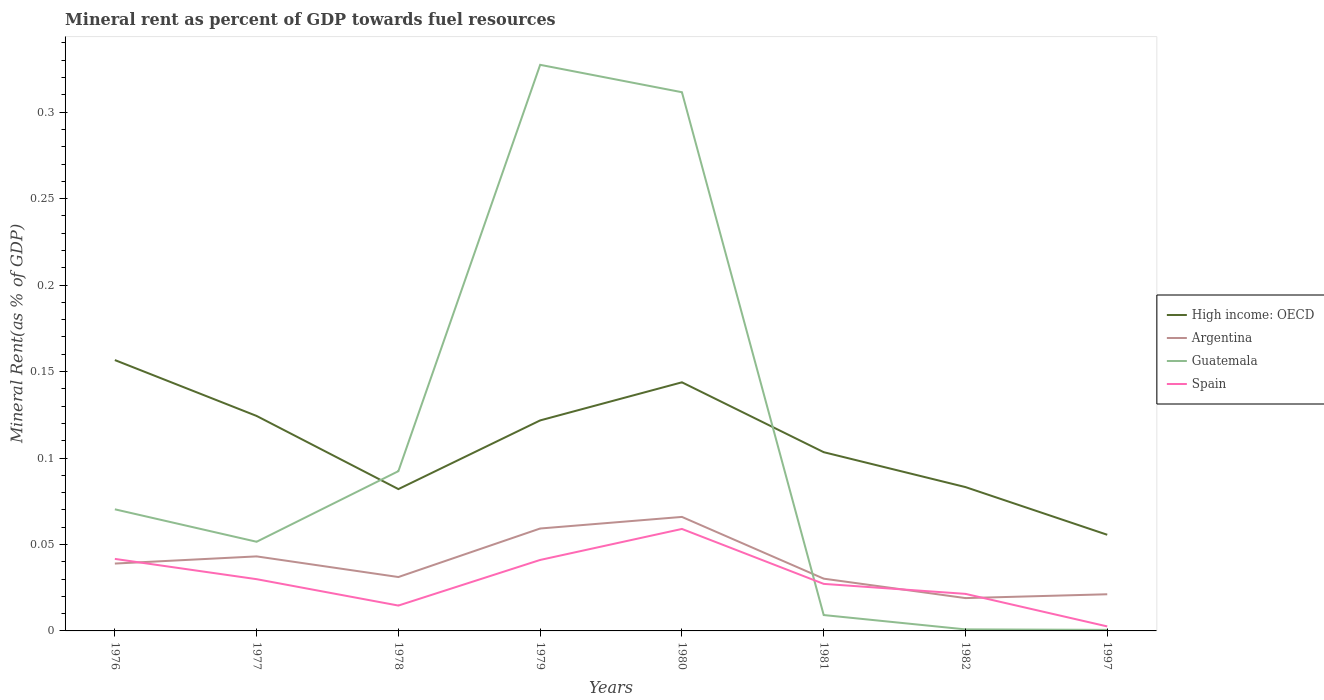How many different coloured lines are there?
Offer a terse response. 4. Does the line corresponding to High income: OECD intersect with the line corresponding to Guatemala?
Your response must be concise. Yes. Across all years, what is the maximum mineral rent in Spain?
Provide a succinct answer. 0. What is the total mineral rent in Guatemala in the graph?
Your answer should be very brief. 0.07. What is the difference between the highest and the second highest mineral rent in Spain?
Your answer should be very brief. 0.06. Is the mineral rent in Argentina strictly greater than the mineral rent in Guatemala over the years?
Ensure brevity in your answer.  No. How many lines are there?
Give a very brief answer. 4. How many years are there in the graph?
Ensure brevity in your answer.  8. Are the values on the major ticks of Y-axis written in scientific E-notation?
Offer a very short reply. No. Where does the legend appear in the graph?
Your answer should be very brief. Center right. How are the legend labels stacked?
Ensure brevity in your answer.  Vertical. What is the title of the graph?
Provide a succinct answer. Mineral rent as percent of GDP towards fuel resources. Does "Indonesia" appear as one of the legend labels in the graph?
Give a very brief answer. No. What is the label or title of the Y-axis?
Give a very brief answer. Mineral Rent(as % of GDP). What is the Mineral Rent(as % of GDP) in High income: OECD in 1976?
Offer a terse response. 0.16. What is the Mineral Rent(as % of GDP) in Argentina in 1976?
Provide a succinct answer. 0.04. What is the Mineral Rent(as % of GDP) of Guatemala in 1976?
Your response must be concise. 0.07. What is the Mineral Rent(as % of GDP) in Spain in 1976?
Your response must be concise. 0.04. What is the Mineral Rent(as % of GDP) of High income: OECD in 1977?
Provide a succinct answer. 0.12. What is the Mineral Rent(as % of GDP) of Argentina in 1977?
Ensure brevity in your answer.  0.04. What is the Mineral Rent(as % of GDP) of Guatemala in 1977?
Offer a very short reply. 0.05. What is the Mineral Rent(as % of GDP) in Spain in 1977?
Provide a short and direct response. 0.03. What is the Mineral Rent(as % of GDP) in High income: OECD in 1978?
Give a very brief answer. 0.08. What is the Mineral Rent(as % of GDP) of Argentina in 1978?
Provide a short and direct response. 0.03. What is the Mineral Rent(as % of GDP) of Guatemala in 1978?
Ensure brevity in your answer.  0.09. What is the Mineral Rent(as % of GDP) in Spain in 1978?
Make the answer very short. 0.01. What is the Mineral Rent(as % of GDP) of High income: OECD in 1979?
Make the answer very short. 0.12. What is the Mineral Rent(as % of GDP) in Argentina in 1979?
Ensure brevity in your answer.  0.06. What is the Mineral Rent(as % of GDP) of Guatemala in 1979?
Keep it short and to the point. 0.33. What is the Mineral Rent(as % of GDP) of Spain in 1979?
Offer a terse response. 0.04. What is the Mineral Rent(as % of GDP) of High income: OECD in 1980?
Offer a terse response. 0.14. What is the Mineral Rent(as % of GDP) in Argentina in 1980?
Keep it short and to the point. 0.07. What is the Mineral Rent(as % of GDP) of Guatemala in 1980?
Keep it short and to the point. 0.31. What is the Mineral Rent(as % of GDP) in Spain in 1980?
Keep it short and to the point. 0.06. What is the Mineral Rent(as % of GDP) in High income: OECD in 1981?
Your answer should be compact. 0.1. What is the Mineral Rent(as % of GDP) of Argentina in 1981?
Your response must be concise. 0.03. What is the Mineral Rent(as % of GDP) of Guatemala in 1981?
Your response must be concise. 0.01. What is the Mineral Rent(as % of GDP) of Spain in 1981?
Provide a short and direct response. 0.03. What is the Mineral Rent(as % of GDP) in High income: OECD in 1982?
Ensure brevity in your answer.  0.08. What is the Mineral Rent(as % of GDP) in Argentina in 1982?
Ensure brevity in your answer.  0.02. What is the Mineral Rent(as % of GDP) in Guatemala in 1982?
Offer a very short reply. 0. What is the Mineral Rent(as % of GDP) in Spain in 1982?
Make the answer very short. 0.02. What is the Mineral Rent(as % of GDP) in High income: OECD in 1997?
Give a very brief answer. 0.06. What is the Mineral Rent(as % of GDP) of Argentina in 1997?
Make the answer very short. 0.02. What is the Mineral Rent(as % of GDP) of Guatemala in 1997?
Your answer should be compact. 0. What is the Mineral Rent(as % of GDP) of Spain in 1997?
Provide a short and direct response. 0. Across all years, what is the maximum Mineral Rent(as % of GDP) of High income: OECD?
Your response must be concise. 0.16. Across all years, what is the maximum Mineral Rent(as % of GDP) of Argentina?
Keep it short and to the point. 0.07. Across all years, what is the maximum Mineral Rent(as % of GDP) in Guatemala?
Provide a succinct answer. 0.33. Across all years, what is the maximum Mineral Rent(as % of GDP) of Spain?
Provide a succinct answer. 0.06. Across all years, what is the minimum Mineral Rent(as % of GDP) in High income: OECD?
Your answer should be compact. 0.06. Across all years, what is the minimum Mineral Rent(as % of GDP) in Argentina?
Your response must be concise. 0.02. Across all years, what is the minimum Mineral Rent(as % of GDP) in Guatemala?
Give a very brief answer. 0. Across all years, what is the minimum Mineral Rent(as % of GDP) of Spain?
Your response must be concise. 0. What is the total Mineral Rent(as % of GDP) in High income: OECD in the graph?
Make the answer very short. 0.87. What is the total Mineral Rent(as % of GDP) in Argentina in the graph?
Provide a succinct answer. 0.31. What is the total Mineral Rent(as % of GDP) in Guatemala in the graph?
Offer a very short reply. 0.86. What is the total Mineral Rent(as % of GDP) of Spain in the graph?
Provide a succinct answer. 0.24. What is the difference between the Mineral Rent(as % of GDP) of High income: OECD in 1976 and that in 1977?
Your answer should be very brief. 0.03. What is the difference between the Mineral Rent(as % of GDP) of Argentina in 1976 and that in 1977?
Ensure brevity in your answer.  -0. What is the difference between the Mineral Rent(as % of GDP) in Guatemala in 1976 and that in 1977?
Provide a short and direct response. 0.02. What is the difference between the Mineral Rent(as % of GDP) of Spain in 1976 and that in 1977?
Your answer should be compact. 0.01. What is the difference between the Mineral Rent(as % of GDP) in High income: OECD in 1976 and that in 1978?
Keep it short and to the point. 0.07. What is the difference between the Mineral Rent(as % of GDP) of Argentina in 1976 and that in 1978?
Your response must be concise. 0.01. What is the difference between the Mineral Rent(as % of GDP) in Guatemala in 1976 and that in 1978?
Make the answer very short. -0.02. What is the difference between the Mineral Rent(as % of GDP) of Spain in 1976 and that in 1978?
Make the answer very short. 0.03. What is the difference between the Mineral Rent(as % of GDP) of High income: OECD in 1976 and that in 1979?
Keep it short and to the point. 0.03. What is the difference between the Mineral Rent(as % of GDP) in Argentina in 1976 and that in 1979?
Keep it short and to the point. -0.02. What is the difference between the Mineral Rent(as % of GDP) in Guatemala in 1976 and that in 1979?
Provide a succinct answer. -0.26. What is the difference between the Mineral Rent(as % of GDP) of Spain in 1976 and that in 1979?
Offer a very short reply. 0. What is the difference between the Mineral Rent(as % of GDP) of High income: OECD in 1976 and that in 1980?
Give a very brief answer. 0.01. What is the difference between the Mineral Rent(as % of GDP) of Argentina in 1976 and that in 1980?
Provide a short and direct response. -0.03. What is the difference between the Mineral Rent(as % of GDP) of Guatemala in 1976 and that in 1980?
Your response must be concise. -0.24. What is the difference between the Mineral Rent(as % of GDP) of Spain in 1976 and that in 1980?
Your answer should be very brief. -0.02. What is the difference between the Mineral Rent(as % of GDP) in High income: OECD in 1976 and that in 1981?
Provide a succinct answer. 0.05. What is the difference between the Mineral Rent(as % of GDP) of Argentina in 1976 and that in 1981?
Your answer should be very brief. 0.01. What is the difference between the Mineral Rent(as % of GDP) in Guatemala in 1976 and that in 1981?
Your answer should be very brief. 0.06. What is the difference between the Mineral Rent(as % of GDP) in Spain in 1976 and that in 1981?
Make the answer very short. 0.01. What is the difference between the Mineral Rent(as % of GDP) of High income: OECD in 1976 and that in 1982?
Offer a very short reply. 0.07. What is the difference between the Mineral Rent(as % of GDP) in Guatemala in 1976 and that in 1982?
Provide a succinct answer. 0.07. What is the difference between the Mineral Rent(as % of GDP) of Spain in 1976 and that in 1982?
Provide a succinct answer. 0.02. What is the difference between the Mineral Rent(as % of GDP) of High income: OECD in 1976 and that in 1997?
Give a very brief answer. 0.1. What is the difference between the Mineral Rent(as % of GDP) of Argentina in 1976 and that in 1997?
Offer a terse response. 0.02. What is the difference between the Mineral Rent(as % of GDP) of Guatemala in 1976 and that in 1997?
Give a very brief answer. 0.07. What is the difference between the Mineral Rent(as % of GDP) in Spain in 1976 and that in 1997?
Provide a succinct answer. 0.04. What is the difference between the Mineral Rent(as % of GDP) of High income: OECD in 1977 and that in 1978?
Your response must be concise. 0.04. What is the difference between the Mineral Rent(as % of GDP) in Argentina in 1977 and that in 1978?
Your answer should be very brief. 0.01. What is the difference between the Mineral Rent(as % of GDP) in Guatemala in 1977 and that in 1978?
Your response must be concise. -0.04. What is the difference between the Mineral Rent(as % of GDP) of Spain in 1977 and that in 1978?
Make the answer very short. 0.02. What is the difference between the Mineral Rent(as % of GDP) of High income: OECD in 1977 and that in 1979?
Offer a very short reply. 0. What is the difference between the Mineral Rent(as % of GDP) in Argentina in 1977 and that in 1979?
Keep it short and to the point. -0.02. What is the difference between the Mineral Rent(as % of GDP) of Guatemala in 1977 and that in 1979?
Make the answer very short. -0.28. What is the difference between the Mineral Rent(as % of GDP) of Spain in 1977 and that in 1979?
Your response must be concise. -0.01. What is the difference between the Mineral Rent(as % of GDP) of High income: OECD in 1977 and that in 1980?
Ensure brevity in your answer.  -0.02. What is the difference between the Mineral Rent(as % of GDP) of Argentina in 1977 and that in 1980?
Provide a short and direct response. -0.02. What is the difference between the Mineral Rent(as % of GDP) in Guatemala in 1977 and that in 1980?
Give a very brief answer. -0.26. What is the difference between the Mineral Rent(as % of GDP) in Spain in 1977 and that in 1980?
Offer a terse response. -0.03. What is the difference between the Mineral Rent(as % of GDP) in High income: OECD in 1977 and that in 1981?
Keep it short and to the point. 0.02. What is the difference between the Mineral Rent(as % of GDP) of Argentina in 1977 and that in 1981?
Ensure brevity in your answer.  0.01. What is the difference between the Mineral Rent(as % of GDP) in Guatemala in 1977 and that in 1981?
Make the answer very short. 0.04. What is the difference between the Mineral Rent(as % of GDP) in Spain in 1977 and that in 1981?
Provide a short and direct response. 0. What is the difference between the Mineral Rent(as % of GDP) in High income: OECD in 1977 and that in 1982?
Your answer should be compact. 0.04. What is the difference between the Mineral Rent(as % of GDP) of Argentina in 1977 and that in 1982?
Offer a very short reply. 0.02. What is the difference between the Mineral Rent(as % of GDP) of Guatemala in 1977 and that in 1982?
Make the answer very short. 0.05. What is the difference between the Mineral Rent(as % of GDP) in Spain in 1977 and that in 1982?
Your response must be concise. 0.01. What is the difference between the Mineral Rent(as % of GDP) in High income: OECD in 1977 and that in 1997?
Your answer should be compact. 0.07. What is the difference between the Mineral Rent(as % of GDP) of Argentina in 1977 and that in 1997?
Offer a very short reply. 0.02. What is the difference between the Mineral Rent(as % of GDP) of Guatemala in 1977 and that in 1997?
Your answer should be compact. 0.05. What is the difference between the Mineral Rent(as % of GDP) of Spain in 1977 and that in 1997?
Provide a succinct answer. 0.03. What is the difference between the Mineral Rent(as % of GDP) in High income: OECD in 1978 and that in 1979?
Your answer should be compact. -0.04. What is the difference between the Mineral Rent(as % of GDP) in Argentina in 1978 and that in 1979?
Offer a terse response. -0.03. What is the difference between the Mineral Rent(as % of GDP) of Guatemala in 1978 and that in 1979?
Give a very brief answer. -0.23. What is the difference between the Mineral Rent(as % of GDP) of Spain in 1978 and that in 1979?
Offer a very short reply. -0.03. What is the difference between the Mineral Rent(as % of GDP) of High income: OECD in 1978 and that in 1980?
Provide a succinct answer. -0.06. What is the difference between the Mineral Rent(as % of GDP) of Argentina in 1978 and that in 1980?
Keep it short and to the point. -0.03. What is the difference between the Mineral Rent(as % of GDP) of Guatemala in 1978 and that in 1980?
Ensure brevity in your answer.  -0.22. What is the difference between the Mineral Rent(as % of GDP) in Spain in 1978 and that in 1980?
Offer a very short reply. -0.04. What is the difference between the Mineral Rent(as % of GDP) in High income: OECD in 1978 and that in 1981?
Ensure brevity in your answer.  -0.02. What is the difference between the Mineral Rent(as % of GDP) in Argentina in 1978 and that in 1981?
Provide a short and direct response. 0. What is the difference between the Mineral Rent(as % of GDP) in Guatemala in 1978 and that in 1981?
Provide a short and direct response. 0.08. What is the difference between the Mineral Rent(as % of GDP) of Spain in 1978 and that in 1981?
Provide a short and direct response. -0.01. What is the difference between the Mineral Rent(as % of GDP) in High income: OECD in 1978 and that in 1982?
Offer a terse response. -0. What is the difference between the Mineral Rent(as % of GDP) in Argentina in 1978 and that in 1982?
Offer a terse response. 0.01. What is the difference between the Mineral Rent(as % of GDP) in Guatemala in 1978 and that in 1982?
Your answer should be compact. 0.09. What is the difference between the Mineral Rent(as % of GDP) in Spain in 1978 and that in 1982?
Your response must be concise. -0.01. What is the difference between the Mineral Rent(as % of GDP) in High income: OECD in 1978 and that in 1997?
Offer a very short reply. 0.03. What is the difference between the Mineral Rent(as % of GDP) of Argentina in 1978 and that in 1997?
Offer a very short reply. 0.01. What is the difference between the Mineral Rent(as % of GDP) in Guatemala in 1978 and that in 1997?
Offer a very short reply. 0.09. What is the difference between the Mineral Rent(as % of GDP) in Spain in 1978 and that in 1997?
Ensure brevity in your answer.  0.01. What is the difference between the Mineral Rent(as % of GDP) of High income: OECD in 1979 and that in 1980?
Provide a succinct answer. -0.02. What is the difference between the Mineral Rent(as % of GDP) of Argentina in 1979 and that in 1980?
Keep it short and to the point. -0.01. What is the difference between the Mineral Rent(as % of GDP) of Guatemala in 1979 and that in 1980?
Offer a very short reply. 0.02. What is the difference between the Mineral Rent(as % of GDP) in Spain in 1979 and that in 1980?
Make the answer very short. -0.02. What is the difference between the Mineral Rent(as % of GDP) in High income: OECD in 1979 and that in 1981?
Your answer should be very brief. 0.02. What is the difference between the Mineral Rent(as % of GDP) in Argentina in 1979 and that in 1981?
Give a very brief answer. 0.03. What is the difference between the Mineral Rent(as % of GDP) in Guatemala in 1979 and that in 1981?
Offer a terse response. 0.32. What is the difference between the Mineral Rent(as % of GDP) of Spain in 1979 and that in 1981?
Offer a terse response. 0.01. What is the difference between the Mineral Rent(as % of GDP) in High income: OECD in 1979 and that in 1982?
Make the answer very short. 0.04. What is the difference between the Mineral Rent(as % of GDP) in Argentina in 1979 and that in 1982?
Your response must be concise. 0.04. What is the difference between the Mineral Rent(as % of GDP) of Guatemala in 1979 and that in 1982?
Provide a short and direct response. 0.33. What is the difference between the Mineral Rent(as % of GDP) in Spain in 1979 and that in 1982?
Provide a short and direct response. 0.02. What is the difference between the Mineral Rent(as % of GDP) in High income: OECD in 1979 and that in 1997?
Make the answer very short. 0.07. What is the difference between the Mineral Rent(as % of GDP) of Argentina in 1979 and that in 1997?
Make the answer very short. 0.04. What is the difference between the Mineral Rent(as % of GDP) in Guatemala in 1979 and that in 1997?
Offer a terse response. 0.33. What is the difference between the Mineral Rent(as % of GDP) of Spain in 1979 and that in 1997?
Provide a succinct answer. 0.04. What is the difference between the Mineral Rent(as % of GDP) in High income: OECD in 1980 and that in 1981?
Your answer should be compact. 0.04. What is the difference between the Mineral Rent(as % of GDP) of Argentina in 1980 and that in 1981?
Provide a short and direct response. 0.04. What is the difference between the Mineral Rent(as % of GDP) in Guatemala in 1980 and that in 1981?
Offer a terse response. 0.3. What is the difference between the Mineral Rent(as % of GDP) in Spain in 1980 and that in 1981?
Make the answer very short. 0.03. What is the difference between the Mineral Rent(as % of GDP) of High income: OECD in 1980 and that in 1982?
Keep it short and to the point. 0.06. What is the difference between the Mineral Rent(as % of GDP) in Argentina in 1980 and that in 1982?
Provide a short and direct response. 0.05. What is the difference between the Mineral Rent(as % of GDP) in Guatemala in 1980 and that in 1982?
Provide a succinct answer. 0.31. What is the difference between the Mineral Rent(as % of GDP) of Spain in 1980 and that in 1982?
Your answer should be very brief. 0.04. What is the difference between the Mineral Rent(as % of GDP) of High income: OECD in 1980 and that in 1997?
Ensure brevity in your answer.  0.09. What is the difference between the Mineral Rent(as % of GDP) in Argentina in 1980 and that in 1997?
Your answer should be compact. 0.04. What is the difference between the Mineral Rent(as % of GDP) of Guatemala in 1980 and that in 1997?
Give a very brief answer. 0.31. What is the difference between the Mineral Rent(as % of GDP) of Spain in 1980 and that in 1997?
Ensure brevity in your answer.  0.06. What is the difference between the Mineral Rent(as % of GDP) of High income: OECD in 1981 and that in 1982?
Provide a succinct answer. 0.02. What is the difference between the Mineral Rent(as % of GDP) of Argentina in 1981 and that in 1982?
Provide a succinct answer. 0.01. What is the difference between the Mineral Rent(as % of GDP) of Guatemala in 1981 and that in 1982?
Your answer should be very brief. 0.01. What is the difference between the Mineral Rent(as % of GDP) in Spain in 1981 and that in 1982?
Offer a very short reply. 0.01. What is the difference between the Mineral Rent(as % of GDP) of High income: OECD in 1981 and that in 1997?
Your response must be concise. 0.05. What is the difference between the Mineral Rent(as % of GDP) of Argentina in 1981 and that in 1997?
Keep it short and to the point. 0.01. What is the difference between the Mineral Rent(as % of GDP) in Guatemala in 1981 and that in 1997?
Provide a short and direct response. 0.01. What is the difference between the Mineral Rent(as % of GDP) of Spain in 1981 and that in 1997?
Offer a terse response. 0.02. What is the difference between the Mineral Rent(as % of GDP) in High income: OECD in 1982 and that in 1997?
Offer a very short reply. 0.03. What is the difference between the Mineral Rent(as % of GDP) of Argentina in 1982 and that in 1997?
Your answer should be very brief. -0. What is the difference between the Mineral Rent(as % of GDP) in Spain in 1982 and that in 1997?
Provide a short and direct response. 0.02. What is the difference between the Mineral Rent(as % of GDP) in High income: OECD in 1976 and the Mineral Rent(as % of GDP) in Argentina in 1977?
Your response must be concise. 0.11. What is the difference between the Mineral Rent(as % of GDP) in High income: OECD in 1976 and the Mineral Rent(as % of GDP) in Guatemala in 1977?
Your response must be concise. 0.11. What is the difference between the Mineral Rent(as % of GDP) in High income: OECD in 1976 and the Mineral Rent(as % of GDP) in Spain in 1977?
Give a very brief answer. 0.13. What is the difference between the Mineral Rent(as % of GDP) of Argentina in 1976 and the Mineral Rent(as % of GDP) of Guatemala in 1977?
Provide a short and direct response. -0.01. What is the difference between the Mineral Rent(as % of GDP) in Argentina in 1976 and the Mineral Rent(as % of GDP) in Spain in 1977?
Offer a terse response. 0.01. What is the difference between the Mineral Rent(as % of GDP) in Guatemala in 1976 and the Mineral Rent(as % of GDP) in Spain in 1977?
Your response must be concise. 0.04. What is the difference between the Mineral Rent(as % of GDP) in High income: OECD in 1976 and the Mineral Rent(as % of GDP) in Argentina in 1978?
Keep it short and to the point. 0.13. What is the difference between the Mineral Rent(as % of GDP) in High income: OECD in 1976 and the Mineral Rent(as % of GDP) in Guatemala in 1978?
Make the answer very short. 0.06. What is the difference between the Mineral Rent(as % of GDP) in High income: OECD in 1976 and the Mineral Rent(as % of GDP) in Spain in 1978?
Your response must be concise. 0.14. What is the difference between the Mineral Rent(as % of GDP) of Argentina in 1976 and the Mineral Rent(as % of GDP) of Guatemala in 1978?
Your answer should be compact. -0.05. What is the difference between the Mineral Rent(as % of GDP) in Argentina in 1976 and the Mineral Rent(as % of GDP) in Spain in 1978?
Ensure brevity in your answer.  0.02. What is the difference between the Mineral Rent(as % of GDP) in Guatemala in 1976 and the Mineral Rent(as % of GDP) in Spain in 1978?
Your answer should be very brief. 0.06. What is the difference between the Mineral Rent(as % of GDP) of High income: OECD in 1976 and the Mineral Rent(as % of GDP) of Argentina in 1979?
Your answer should be compact. 0.1. What is the difference between the Mineral Rent(as % of GDP) in High income: OECD in 1976 and the Mineral Rent(as % of GDP) in Guatemala in 1979?
Offer a very short reply. -0.17. What is the difference between the Mineral Rent(as % of GDP) in High income: OECD in 1976 and the Mineral Rent(as % of GDP) in Spain in 1979?
Your response must be concise. 0.12. What is the difference between the Mineral Rent(as % of GDP) of Argentina in 1976 and the Mineral Rent(as % of GDP) of Guatemala in 1979?
Your answer should be compact. -0.29. What is the difference between the Mineral Rent(as % of GDP) of Argentina in 1976 and the Mineral Rent(as % of GDP) of Spain in 1979?
Your answer should be very brief. -0. What is the difference between the Mineral Rent(as % of GDP) of Guatemala in 1976 and the Mineral Rent(as % of GDP) of Spain in 1979?
Your answer should be compact. 0.03. What is the difference between the Mineral Rent(as % of GDP) in High income: OECD in 1976 and the Mineral Rent(as % of GDP) in Argentina in 1980?
Ensure brevity in your answer.  0.09. What is the difference between the Mineral Rent(as % of GDP) in High income: OECD in 1976 and the Mineral Rent(as % of GDP) in Guatemala in 1980?
Your answer should be very brief. -0.15. What is the difference between the Mineral Rent(as % of GDP) in High income: OECD in 1976 and the Mineral Rent(as % of GDP) in Spain in 1980?
Your answer should be very brief. 0.1. What is the difference between the Mineral Rent(as % of GDP) of Argentina in 1976 and the Mineral Rent(as % of GDP) of Guatemala in 1980?
Give a very brief answer. -0.27. What is the difference between the Mineral Rent(as % of GDP) in Argentina in 1976 and the Mineral Rent(as % of GDP) in Spain in 1980?
Make the answer very short. -0.02. What is the difference between the Mineral Rent(as % of GDP) of Guatemala in 1976 and the Mineral Rent(as % of GDP) of Spain in 1980?
Provide a short and direct response. 0.01. What is the difference between the Mineral Rent(as % of GDP) in High income: OECD in 1976 and the Mineral Rent(as % of GDP) in Argentina in 1981?
Keep it short and to the point. 0.13. What is the difference between the Mineral Rent(as % of GDP) in High income: OECD in 1976 and the Mineral Rent(as % of GDP) in Guatemala in 1981?
Keep it short and to the point. 0.15. What is the difference between the Mineral Rent(as % of GDP) of High income: OECD in 1976 and the Mineral Rent(as % of GDP) of Spain in 1981?
Give a very brief answer. 0.13. What is the difference between the Mineral Rent(as % of GDP) of Argentina in 1976 and the Mineral Rent(as % of GDP) of Guatemala in 1981?
Offer a terse response. 0.03. What is the difference between the Mineral Rent(as % of GDP) in Argentina in 1976 and the Mineral Rent(as % of GDP) in Spain in 1981?
Offer a very short reply. 0.01. What is the difference between the Mineral Rent(as % of GDP) of Guatemala in 1976 and the Mineral Rent(as % of GDP) of Spain in 1981?
Make the answer very short. 0.04. What is the difference between the Mineral Rent(as % of GDP) in High income: OECD in 1976 and the Mineral Rent(as % of GDP) in Argentina in 1982?
Ensure brevity in your answer.  0.14. What is the difference between the Mineral Rent(as % of GDP) of High income: OECD in 1976 and the Mineral Rent(as % of GDP) of Guatemala in 1982?
Make the answer very short. 0.16. What is the difference between the Mineral Rent(as % of GDP) in High income: OECD in 1976 and the Mineral Rent(as % of GDP) in Spain in 1982?
Your answer should be very brief. 0.14. What is the difference between the Mineral Rent(as % of GDP) in Argentina in 1976 and the Mineral Rent(as % of GDP) in Guatemala in 1982?
Give a very brief answer. 0.04. What is the difference between the Mineral Rent(as % of GDP) in Argentina in 1976 and the Mineral Rent(as % of GDP) in Spain in 1982?
Offer a terse response. 0.02. What is the difference between the Mineral Rent(as % of GDP) of Guatemala in 1976 and the Mineral Rent(as % of GDP) of Spain in 1982?
Your answer should be very brief. 0.05. What is the difference between the Mineral Rent(as % of GDP) in High income: OECD in 1976 and the Mineral Rent(as % of GDP) in Argentina in 1997?
Ensure brevity in your answer.  0.14. What is the difference between the Mineral Rent(as % of GDP) in High income: OECD in 1976 and the Mineral Rent(as % of GDP) in Guatemala in 1997?
Provide a succinct answer. 0.16. What is the difference between the Mineral Rent(as % of GDP) in High income: OECD in 1976 and the Mineral Rent(as % of GDP) in Spain in 1997?
Your answer should be compact. 0.15. What is the difference between the Mineral Rent(as % of GDP) of Argentina in 1976 and the Mineral Rent(as % of GDP) of Guatemala in 1997?
Your answer should be very brief. 0.04. What is the difference between the Mineral Rent(as % of GDP) of Argentina in 1976 and the Mineral Rent(as % of GDP) of Spain in 1997?
Your response must be concise. 0.04. What is the difference between the Mineral Rent(as % of GDP) in Guatemala in 1976 and the Mineral Rent(as % of GDP) in Spain in 1997?
Ensure brevity in your answer.  0.07. What is the difference between the Mineral Rent(as % of GDP) of High income: OECD in 1977 and the Mineral Rent(as % of GDP) of Argentina in 1978?
Your answer should be compact. 0.09. What is the difference between the Mineral Rent(as % of GDP) of High income: OECD in 1977 and the Mineral Rent(as % of GDP) of Guatemala in 1978?
Make the answer very short. 0.03. What is the difference between the Mineral Rent(as % of GDP) of High income: OECD in 1977 and the Mineral Rent(as % of GDP) of Spain in 1978?
Offer a terse response. 0.11. What is the difference between the Mineral Rent(as % of GDP) of Argentina in 1977 and the Mineral Rent(as % of GDP) of Guatemala in 1978?
Make the answer very short. -0.05. What is the difference between the Mineral Rent(as % of GDP) in Argentina in 1977 and the Mineral Rent(as % of GDP) in Spain in 1978?
Keep it short and to the point. 0.03. What is the difference between the Mineral Rent(as % of GDP) in Guatemala in 1977 and the Mineral Rent(as % of GDP) in Spain in 1978?
Make the answer very short. 0.04. What is the difference between the Mineral Rent(as % of GDP) of High income: OECD in 1977 and the Mineral Rent(as % of GDP) of Argentina in 1979?
Offer a terse response. 0.07. What is the difference between the Mineral Rent(as % of GDP) of High income: OECD in 1977 and the Mineral Rent(as % of GDP) of Guatemala in 1979?
Give a very brief answer. -0.2. What is the difference between the Mineral Rent(as % of GDP) in High income: OECD in 1977 and the Mineral Rent(as % of GDP) in Spain in 1979?
Provide a succinct answer. 0.08. What is the difference between the Mineral Rent(as % of GDP) in Argentina in 1977 and the Mineral Rent(as % of GDP) in Guatemala in 1979?
Make the answer very short. -0.28. What is the difference between the Mineral Rent(as % of GDP) of Argentina in 1977 and the Mineral Rent(as % of GDP) of Spain in 1979?
Provide a succinct answer. 0. What is the difference between the Mineral Rent(as % of GDP) of Guatemala in 1977 and the Mineral Rent(as % of GDP) of Spain in 1979?
Your response must be concise. 0.01. What is the difference between the Mineral Rent(as % of GDP) in High income: OECD in 1977 and the Mineral Rent(as % of GDP) in Argentina in 1980?
Your answer should be very brief. 0.06. What is the difference between the Mineral Rent(as % of GDP) of High income: OECD in 1977 and the Mineral Rent(as % of GDP) of Guatemala in 1980?
Offer a very short reply. -0.19. What is the difference between the Mineral Rent(as % of GDP) of High income: OECD in 1977 and the Mineral Rent(as % of GDP) of Spain in 1980?
Keep it short and to the point. 0.07. What is the difference between the Mineral Rent(as % of GDP) of Argentina in 1977 and the Mineral Rent(as % of GDP) of Guatemala in 1980?
Provide a succinct answer. -0.27. What is the difference between the Mineral Rent(as % of GDP) in Argentina in 1977 and the Mineral Rent(as % of GDP) in Spain in 1980?
Ensure brevity in your answer.  -0.02. What is the difference between the Mineral Rent(as % of GDP) in Guatemala in 1977 and the Mineral Rent(as % of GDP) in Spain in 1980?
Your answer should be very brief. -0.01. What is the difference between the Mineral Rent(as % of GDP) in High income: OECD in 1977 and the Mineral Rent(as % of GDP) in Argentina in 1981?
Offer a very short reply. 0.09. What is the difference between the Mineral Rent(as % of GDP) in High income: OECD in 1977 and the Mineral Rent(as % of GDP) in Guatemala in 1981?
Keep it short and to the point. 0.12. What is the difference between the Mineral Rent(as % of GDP) in High income: OECD in 1977 and the Mineral Rent(as % of GDP) in Spain in 1981?
Keep it short and to the point. 0.1. What is the difference between the Mineral Rent(as % of GDP) of Argentina in 1977 and the Mineral Rent(as % of GDP) of Guatemala in 1981?
Provide a short and direct response. 0.03. What is the difference between the Mineral Rent(as % of GDP) in Argentina in 1977 and the Mineral Rent(as % of GDP) in Spain in 1981?
Provide a succinct answer. 0.02. What is the difference between the Mineral Rent(as % of GDP) in Guatemala in 1977 and the Mineral Rent(as % of GDP) in Spain in 1981?
Offer a terse response. 0.02. What is the difference between the Mineral Rent(as % of GDP) in High income: OECD in 1977 and the Mineral Rent(as % of GDP) in Argentina in 1982?
Offer a very short reply. 0.11. What is the difference between the Mineral Rent(as % of GDP) in High income: OECD in 1977 and the Mineral Rent(as % of GDP) in Guatemala in 1982?
Give a very brief answer. 0.12. What is the difference between the Mineral Rent(as % of GDP) of High income: OECD in 1977 and the Mineral Rent(as % of GDP) of Spain in 1982?
Keep it short and to the point. 0.1. What is the difference between the Mineral Rent(as % of GDP) in Argentina in 1977 and the Mineral Rent(as % of GDP) in Guatemala in 1982?
Keep it short and to the point. 0.04. What is the difference between the Mineral Rent(as % of GDP) of Argentina in 1977 and the Mineral Rent(as % of GDP) of Spain in 1982?
Make the answer very short. 0.02. What is the difference between the Mineral Rent(as % of GDP) in Guatemala in 1977 and the Mineral Rent(as % of GDP) in Spain in 1982?
Make the answer very short. 0.03. What is the difference between the Mineral Rent(as % of GDP) of High income: OECD in 1977 and the Mineral Rent(as % of GDP) of Argentina in 1997?
Provide a short and direct response. 0.1. What is the difference between the Mineral Rent(as % of GDP) of High income: OECD in 1977 and the Mineral Rent(as % of GDP) of Guatemala in 1997?
Your answer should be very brief. 0.12. What is the difference between the Mineral Rent(as % of GDP) of High income: OECD in 1977 and the Mineral Rent(as % of GDP) of Spain in 1997?
Your response must be concise. 0.12. What is the difference between the Mineral Rent(as % of GDP) of Argentina in 1977 and the Mineral Rent(as % of GDP) of Guatemala in 1997?
Ensure brevity in your answer.  0.04. What is the difference between the Mineral Rent(as % of GDP) of Argentina in 1977 and the Mineral Rent(as % of GDP) of Spain in 1997?
Keep it short and to the point. 0.04. What is the difference between the Mineral Rent(as % of GDP) of Guatemala in 1977 and the Mineral Rent(as % of GDP) of Spain in 1997?
Provide a succinct answer. 0.05. What is the difference between the Mineral Rent(as % of GDP) of High income: OECD in 1978 and the Mineral Rent(as % of GDP) of Argentina in 1979?
Ensure brevity in your answer.  0.02. What is the difference between the Mineral Rent(as % of GDP) of High income: OECD in 1978 and the Mineral Rent(as % of GDP) of Guatemala in 1979?
Your response must be concise. -0.25. What is the difference between the Mineral Rent(as % of GDP) of High income: OECD in 1978 and the Mineral Rent(as % of GDP) of Spain in 1979?
Provide a short and direct response. 0.04. What is the difference between the Mineral Rent(as % of GDP) of Argentina in 1978 and the Mineral Rent(as % of GDP) of Guatemala in 1979?
Your response must be concise. -0.3. What is the difference between the Mineral Rent(as % of GDP) of Argentina in 1978 and the Mineral Rent(as % of GDP) of Spain in 1979?
Your answer should be very brief. -0.01. What is the difference between the Mineral Rent(as % of GDP) of Guatemala in 1978 and the Mineral Rent(as % of GDP) of Spain in 1979?
Give a very brief answer. 0.05. What is the difference between the Mineral Rent(as % of GDP) in High income: OECD in 1978 and the Mineral Rent(as % of GDP) in Argentina in 1980?
Ensure brevity in your answer.  0.02. What is the difference between the Mineral Rent(as % of GDP) in High income: OECD in 1978 and the Mineral Rent(as % of GDP) in Guatemala in 1980?
Make the answer very short. -0.23. What is the difference between the Mineral Rent(as % of GDP) in High income: OECD in 1978 and the Mineral Rent(as % of GDP) in Spain in 1980?
Your response must be concise. 0.02. What is the difference between the Mineral Rent(as % of GDP) in Argentina in 1978 and the Mineral Rent(as % of GDP) in Guatemala in 1980?
Keep it short and to the point. -0.28. What is the difference between the Mineral Rent(as % of GDP) in Argentina in 1978 and the Mineral Rent(as % of GDP) in Spain in 1980?
Offer a very short reply. -0.03. What is the difference between the Mineral Rent(as % of GDP) of Guatemala in 1978 and the Mineral Rent(as % of GDP) of Spain in 1980?
Offer a terse response. 0.03. What is the difference between the Mineral Rent(as % of GDP) in High income: OECD in 1978 and the Mineral Rent(as % of GDP) in Argentina in 1981?
Your response must be concise. 0.05. What is the difference between the Mineral Rent(as % of GDP) of High income: OECD in 1978 and the Mineral Rent(as % of GDP) of Guatemala in 1981?
Your response must be concise. 0.07. What is the difference between the Mineral Rent(as % of GDP) of High income: OECD in 1978 and the Mineral Rent(as % of GDP) of Spain in 1981?
Give a very brief answer. 0.05. What is the difference between the Mineral Rent(as % of GDP) of Argentina in 1978 and the Mineral Rent(as % of GDP) of Guatemala in 1981?
Ensure brevity in your answer.  0.02. What is the difference between the Mineral Rent(as % of GDP) in Argentina in 1978 and the Mineral Rent(as % of GDP) in Spain in 1981?
Provide a short and direct response. 0. What is the difference between the Mineral Rent(as % of GDP) in Guatemala in 1978 and the Mineral Rent(as % of GDP) in Spain in 1981?
Your answer should be compact. 0.07. What is the difference between the Mineral Rent(as % of GDP) of High income: OECD in 1978 and the Mineral Rent(as % of GDP) of Argentina in 1982?
Offer a terse response. 0.06. What is the difference between the Mineral Rent(as % of GDP) in High income: OECD in 1978 and the Mineral Rent(as % of GDP) in Guatemala in 1982?
Offer a terse response. 0.08. What is the difference between the Mineral Rent(as % of GDP) of High income: OECD in 1978 and the Mineral Rent(as % of GDP) of Spain in 1982?
Your answer should be compact. 0.06. What is the difference between the Mineral Rent(as % of GDP) of Argentina in 1978 and the Mineral Rent(as % of GDP) of Guatemala in 1982?
Your answer should be compact. 0.03. What is the difference between the Mineral Rent(as % of GDP) in Argentina in 1978 and the Mineral Rent(as % of GDP) in Spain in 1982?
Ensure brevity in your answer.  0.01. What is the difference between the Mineral Rent(as % of GDP) in Guatemala in 1978 and the Mineral Rent(as % of GDP) in Spain in 1982?
Keep it short and to the point. 0.07. What is the difference between the Mineral Rent(as % of GDP) in High income: OECD in 1978 and the Mineral Rent(as % of GDP) in Argentina in 1997?
Provide a short and direct response. 0.06. What is the difference between the Mineral Rent(as % of GDP) of High income: OECD in 1978 and the Mineral Rent(as % of GDP) of Guatemala in 1997?
Ensure brevity in your answer.  0.08. What is the difference between the Mineral Rent(as % of GDP) in High income: OECD in 1978 and the Mineral Rent(as % of GDP) in Spain in 1997?
Make the answer very short. 0.08. What is the difference between the Mineral Rent(as % of GDP) of Argentina in 1978 and the Mineral Rent(as % of GDP) of Guatemala in 1997?
Your response must be concise. 0.03. What is the difference between the Mineral Rent(as % of GDP) of Argentina in 1978 and the Mineral Rent(as % of GDP) of Spain in 1997?
Your response must be concise. 0.03. What is the difference between the Mineral Rent(as % of GDP) of Guatemala in 1978 and the Mineral Rent(as % of GDP) of Spain in 1997?
Provide a succinct answer. 0.09. What is the difference between the Mineral Rent(as % of GDP) in High income: OECD in 1979 and the Mineral Rent(as % of GDP) in Argentina in 1980?
Your response must be concise. 0.06. What is the difference between the Mineral Rent(as % of GDP) of High income: OECD in 1979 and the Mineral Rent(as % of GDP) of Guatemala in 1980?
Offer a very short reply. -0.19. What is the difference between the Mineral Rent(as % of GDP) in High income: OECD in 1979 and the Mineral Rent(as % of GDP) in Spain in 1980?
Provide a succinct answer. 0.06. What is the difference between the Mineral Rent(as % of GDP) of Argentina in 1979 and the Mineral Rent(as % of GDP) of Guatemala in 1980?
Your response must be concise. -0.25. What is the difference between the Mineral Rent(as % of GDP) in Guatemala in 1979 and the Mineral Rent(as % of GDP) in Spain in 1980?
Offer a terse response. 0.27. What is the difference between the Mineral Rent(as % of GDP) of High income: OECD in 1979 and the Mineral Rent(as % of GDP) of Argentina in 1981?
Give a very brief answer. 0.09. What is the difference between the Mineral Rent(as % of GDP) of High income: OECD in 1979 and the Mineral Rent(as % of GDP) of Guatemala in 1981?
Give a very brief answer. 0.11. What is the difference between the Mineral Rent(as % of GDP) of High income: OECD in 1979 and the Mineral Rent(as % of GDP) of Spain in 1981?
Keep it short and to the point. 0.09. What is the difference between the Mineral Rent(as % of GDP) of Argentina in 1979 and the Mineral Rent(as % of GDP) of Spain in 1981?
Your answer should be very brief. 0.03. What is the difference between the Mineral Rent(as % of GDP) in Guatemala in 1979 and the Mineral Rent(as % of GDP) in Spain in 1981?
Your response must be concise. 0.3. What is the difference between the Mineral Rent(as % of GDP) of High income: OECD in 1979 and the Mineral Rent(as % of GDP) of Argentina in 1982?
Offer a very short reply. 0.1. What is the difference between the Mineral Rent(as % of GDP) of High income: OECD in 1979 and the Mineral Rent(as % of GDP) of Guatemala in 1982?
Provide a short and direct response. 0.12. What is the difference between the Mineral Rent(as % of GDP) in High income: OECD in 1979 and the Mineral Rent(as % of GDP) in Spain in 1982?
Provide a succinct answer. 0.1. What is the difference between the Mineral Rent(as % of GDP) in Argentina in 1979 and the Mineral Rent(as % of GDP) in Guatemala in 1982?
Provide a succinct answer. 0.06. What is the difference between the Mineral Rent(as % of GDP) in Argentina in 1979 and the Mineral Rent(as % of GDP) in Spain in 1982?
Ensure brevity in your answer.  0.04. What is the difference between the Mineral Rent(as % of GDP) of Guatemala in 1979 and the Mineral Rent(as % of GDP) of Spain in 1982?
Your answer should be very brief. 0.31. What is the difference between the Mineral Rent(as % of GDP) in High income: OECD in 1979 and the Mineral Rent(as % of GDP) in Argentina in 1997?
Give a very brief answer. 0.1. What is the difference between the Mineral Rent(as % of GDP) in High income: OECD in 1979 and the Mineral Rent(as % of GDP) in Guatemala in 1997?
Ensure brevity in your answer.  0.12. What is the difference between the Mineral Rent(as % of GDP) of High income: OECD in 1979 and the Mineral Rent(as % of GDP) of Spain in 1997?
Keep it short and to the point. 0.12. What is the difference between the Mineral Rent(as % of GDP) of Argentina in 1979 and the Mineral Rent(as % of GDP) of Guatemala in 1997?
Offer a terse response. 0.06. What is the difference between the Mineral Rent(as % of GDP) of Argentina in 1979 and the Mineral Rent(as % of GDP) of Spain in 1997?
Ensure brevity in your answer.  0.06. What is the difference between the Mineral Rent(as % of GDP) in Guatemala in 1979 and the Mineral Rent(as % of GDP) in Spain in 1997?
Provide a succinct answer. 0.32. What is the difference between the Mineral Rent(as % of GDP) in High income: OECD in 1980 and the Mineral Rent(as % of GDP) in Argentina in 1981?
Provide a succinct answer. 0.11. What is the difference between the Mineral Rent(as % of GDP) of High income: OECD in 1980 and the Mineral Rent(as % of GDP) of Guatemala in 1981?
Make the answer very short. 0.13. What is the difference between the Mineral Rent(as % of GDP) in High income: OECD in 1980 and the Mineral Rent(as % of GDP) in Spain in 1981?
Your response must be concise. 0.12. What is the difference between the Mineral Rent(as % of GDP) in Argentina in 1980 and the Mineral Rent(as % of GDP) in Guatemala in 1981?
Provide a short and direct response. 0.06. What is the difference between the Mineral Rent(as % of GDP) of Argentina in 1980 and the Mineral Rent(as % of GDP) of Spain in 1981?
Ensure brevity in your answer.  0.04. What is the difference between the Mineral Rent(as % of GDP) of Guatemala in 1980 and the Mineral Rent(as % of GDP) of Spain in 1981?
Offer a terse response. 0.28. What is the difference between the Mineral Rent(as % of GDP) of High income: OECD in 1980 and the Mineral Rent(as % of GDP) of Argentina in 1982?
Keep it short and to the point. 0.12. What is the difference between the Mineral Rent(as % of GDP) of High income: OECD in 1980 and the Mineral Rent(as % of GDP) of Guatemala in 1982?
Ensure brevity in your answer.  0.14. What is the difference between the Mineral Rent(as % of GDP) in High income: OECD in 1980 and the Mineral Rent(as % of GDP) in Spain in 1982?
Offer a very short reply. 0.12. What is the difference between the Mineral Rent(as % of GDP) in Argentina in 1980 and the Mineral Rent(as % of GDP) in Guatemala in 1982?
Keep it short and to the point. 0.07. What is the difference between the Mineral Rent(as % of GDP) in Argentina in 1980 and the Mineral Rent(as % of GDP) in Spain in 1982?
Give a very brief answer. 0.04. What is the difference between the Mineral Rent(as % of GDP) in Guatemala in 1980 and the Mineral Rent(as % of GDP) in Spain in 1982?
Your answer should be very brief. 0.29. What is the difference between the Mineral Rent(as % of GDP) of High income: OECD in 1980 and the Mineral Rent(as % of GDP) of Argentina in 1997?
Offer a very short reply. 0.12. What is the difference between the Mineral Rent(as % of GDP) in High income: OECD in 1980 and the Mineral Rent(as % of GDP) in Guatemala in 1997?
Your response must be concise. 0.14. What is the difference between the Mineral Rent(as % of GDP) in High income: OECD in 1980 and the Mineral Rent(as % of GDP) in Spain in 1997?
Your response must be concise. 0.14. What is the difference between the Mineral Rent(as % of GDP) in Argentina in 1980 and the Mineral Rent(as % of GDP) in Guatemala in 1997?
Keep it short and to the point. 0.07. What is the difference between the Mineral Rent(as % of GDP) in Argentina in 1980 and the Mineral Rent(as % of GDP) in Spain in 1997?
Ensure brevity in your answer.  0.06. What is the difference between the Mineral Rent(as % of GDP) of Guatemala in 1980 and the Mineral Rent(as % of GDP) of Spain in 1997?
Offer a terse response. 0.31. What is the difference between the Mineral Rent(as % of GDP) in High income: OECD in 1981 and the Mineral Rent(as % of GDP) in Argentina in 1982?
Make the answer very short. 0.08. What is the difference between the Mineral Rent(as % of GDP) of High income: OECD in 1981 and the Mineral Rent(as % of GDP) of Guatemala in 1982?
Your answer should be very brief. 0.1. What is the difference between the Mineral Rent(as % of GDP) in High income: OECD in 1981 and the Mineral Rent(as % of GDP) in Spain in 1982?
Make the answer very short. 0.08. What is the difference between the Mineral Rent(as % of GDP) of Argentina in 1981 and the Mineral Rent(as % of GDP) of Guatemala in 1982?
Make the answer very short. 0.03. What is the difference between the Mineral Rent(as % of GDP) of Argentina in 1981 and the Mineral Rent(as % of GDP) of Spain in 1982?
Give a very brief answer. 0.01. What is the difference between the Mineral Rent(as % of GDP) in Guatemala in 1981 and the Mineral Rent(as % of GDP) in Spain in 1982?
Provide a short and direct response. -0.01. What is the difference between the Mineral Rent(as % of GDP) of High income: OECD in 1981 and the Mineral Rent(as % of GDP) of Argentina in 1997?
Offer a very short reply. 0.08. What is the difference between the Mineral Rent(as % of GDP) of High income: OECD in 1981 and the Mineral Rent(as % of GDP) of Guatemala in 1997?
Make the answer very short. 0.1. What is the difference between the Mineral Rent(as % of GDP) of High income: OECD in 1981 and the Mineral Rent(as % of GDP) of Spain in 1997?
Your answer should be very brief. 0.1. What is the difference between the Mineral Rent(as % of GDP) in Argentina in 1981 and the Mineral Rent(as % of GDP) in Guatemala in 1997?
Offer a terse response. 0.03. What is the difference between the Mineral Rent(as % of GDP) in Argentina in 1981 and the Mineral Rent(as % of GDP) in Spain in 1997?
Ensure brevity in your answer.  0.03. What is the difference between the Mineral Rent(as % of GDP) in Guatemala in 1981 and the Mineral Rent(as % of GDP) in Spain in 1997?
Keep it short and to the point. 0.01. What is the difference between the Mineral Rent(as % of GDP) of High income: OECD in 1982 and the Mineral Rent(as % of GDP) of Argentina in 1997?
Ensure brevity in your answer.  0.06. What is the difference between the Mineral Rent(as % of GDP) of High income: OECD in 1982 and the Mineral Rent(as % of GDP) of Guatemala in 1997?
Keep it short and to the point. 0.08. What is the difference between the Mineral Rent(as % of GDP) in High income: OECD in 1982 and the Mineral Rent(as % of GDP) in Spain in 1997?
Your answer should be compact. 0.08. What is the difference between the Mineral Rent(as % of GDP) in Argentina in 1982 and the Mineral Rent(as % of GDP) in Guatemala in 1997?
Your response must be concise. 0.02. What is the difference between the Mineral Rent(as % of GDP) of Argentina in 1982 and the Mineral Rent(as % of GDP) of Spain in 1997?
Provide a succinct answer. 0.02. What is the difference between the Mineral Rent(as % of GDP) of Guatemala in 1982 and the Mineral Rent(as % of GDP) of Spain in 1997?
Provide a succinct answer. -0. What is the average Mineral Rent(as % of GDP) of High income: OECD per year?
Offer a very short reply. 0.11. What is the average Mineral Rent(as % of GDP) of Argentina per year?
Provide a succinct answer. 0.04. What is the average Mineral Rent(as % of GDP) of Guatemala per year?
Make the answer very short. 0.11. What is the average Mineral Rent(as % of GDP) of Spain per year?
Offer a terse response. 0.03. In the year 1976, what is the difference between the Mineral Rent(as % of GDP) of High income: OECD and Mineral Rent(as % of GDP) of Argentina?
Offer a very short reply. 0.12. In the year 1976, what is the difference between the Mineral Rent(as % of GDP) of High income: OECD and Mineral Rent(as % of GDP) of Guatemala?
Offer a terse response. 0.09. In the year 1976, what is the difference between the Mineral Rent(as % of GDP) in High income: OECD and Mineral Rent(as % of GDP) in Spain?
Keep it short and to the point. 0.12. In the year 1976, what is the difference between the Mineral Rent(as % of GDP) of Argentina and Mineral Rent(as % of GDP) of Guatemala?
Make the answer very short. -0.03. In the year 1976, what is the difference between the Mineral Rent(as % of GDP) in Argentina and Mineral Rent(as % of GDP) in Spain?
Provide a short and direct response. -0. In the year 1976, what is the difference between the Mineral Rent(as % of GDP) of Guatemala and Mineral Rent(as % of GDP) of Spain?
Make the answer very short. 0.03. In the year 1977, what is the difference between the Mineral Rent(as % of GDP) in High income: OECD and Mineral Rent(as % of GDP) in Argentina?
Provide a succinct answer. 0.08. In the year 1977, what is the difference between the Mineral Rent(as % of GDP) of High income: OECD and Mineral Rent(as % of GDP) of Guatemala?
Your answer should be very brief. 0.07. In the year 1977, what is the difference between the Mineral Rent(as % of GDP) of High income: OECD and Mineral Rent(as % of GDP) of Spain?
Keep it short and to the point. 0.09. In the year 1977, what is the difference between the Mineral Rent(as % of GDP) in Argentina and Mineral Rent(as % of GDP) in Guatemala?
Make the answer very short. -0.01. In the year 1977, what is the difference between the Mineral Rent(as % of GDP) in Argentina and Mineral Rent(as % of GDP) in Spain?
Offer a very short reply. 0.01. In the year 1977, what is the difference between the Mineral Rent(as % of GDP) of Guatemala and Mineral Rent(as % of GDP) of Spain?
Make the answer very short. 0.02. In the year 1978, what is the difference between the Mineral Rent(as % of GDP) in High income: OECD and Mineral Rent(as % of GDP) in Argentina?
Your answer should be very brief. 0.05. In the year 1978, what is the difference between the Mineral Rent(as % of GDP) of High income: OECD and Mineral Rent(as % of GDP) of Guatemala?
Your answer should be very brief. -0.01. In the year 1978, what is the difference between the Mineral Rent(as % of GDP) of High income: OECD and Mineral Rent(as % of GDP) of Spain?
Provide a succinct answer. 0.07. In the year 1978, what is the difference between the Mineral Rent(as % of GDP) in Argentina and Mineral Rent(as % of GDP) in Guatemala?
Provide a succinct answer. -0.06. In the year 1978, what is the difference between the Mineral Rent(as % of GDP) in Argentina and Mineral Rent(as % of GDP) in Spain?
Give a very brief answer. 0.02. In the year 1978, what is the difference between the Mineral Rent(as % of GDP) in Guatemala and Mineral Rent(as % of GDP) in Spain?
Offer a very short reply. 0.08. In the year 1979, what is the difference between the Mineral Rent(as % of GDP) of High income: OECD and Mineral Rent(as % of GDP) of Argentina?
Give a very brief answer. 0.06. In the year 1979, what is the difference between the Mineral Rent(as % of GDP) in High income: OECD and Mineral Rent(as % of GDP) in Guatemala?
Give a very brief answer. -0.21. In the year 1979, what is the difference between the Mineral Rent(as % of GDP) in High income: OECD and Mineral Rent(as % of GDP) in Spain?
Your answer should be compact. 0.08. In the year 1979, what is the difference between the Mineral Rent(as % of GDP) of Argentina and Mineral Rent(as % of GDP) of Guatemala?
Give a very brief answer. -0.27. In the year 1979, what is the difference between the Mineral Rent(as % of GDP) in Argentina and Mineral Rent(as % of GDP) in Spain?
Give a very brief answer. 0.02. In the year 1979, what is the difference between the Mineral Rent(as % of GDP) in Guatemala and Mineral Rent(as % of GDP) in Spain?
Ensure brevity in your answer.  0.29. In the year 1980, what is the difference between the Mineral Rent(as % of GDP) of High income: OECD and Mineral Rent(as % of GDP) of Argentina?
Keep it short and to the point. 0.08. In the year 1980, what is the difference between the Mineral Rent(as % of GDP) of High income: OECD and Mineral Rent(as % of GDP) of Guatemala?
Offer a very short reply. -0.17. In the year 1980, what is the difference between the Mineral Rent(as % of GDP) of High income: OECD and Mineral Rent(as % of GDP) of Spain?
Your response must be concise. 0.08. In the year 1980, what is the difference between the Mineral Rent(as % of GDP) of Argentina and Mineral Rent(as % of GDP) of Guatemala?
Keep it short and to the point. -0.25. In the year 1980, what is the difference between the Mineral Rent(as % of GDP) of Argentina and Mineral Rent(as % of GDP) of Spain?
Your answer should be very brief. 0.01. In the year 1980, what is the difference between the Mineral Rent(as % of GDP) of Guatemala and Mineral Rent(as % of GDP) of Spain?
Provide a short and direct response. 0.25. In the year 1981, what is the difference between the Mineral Rent(as % of GDP) of High income: OECD and Mineral Rent(as % of GDP) of Argentina?
Offer a very short reply. 0.07. In the year 1981, what is the difference between the Mineral Rent(as % of GDP) of High income: OECD and Mineral Rent(as % of GDP) of Guatemala?
Offer a terse response. 0.09. In the year 1981, what is the difference between the Mineral Rent(as % of GDP) in High income: OECD and Mineral Rent(as % of GDP) in Spain?
Keep it short and to the point. 0.08. In the year 1981, what is the difference between the Mineral Rent(as % of GDP) of Argentina and Mineral Rent(as % of GDP) of Guatemala?
Provide a succinct answer. 0.02. In the year 1981, what is the difference between the Mineral Rent(as % of GDP) in Argentina and Mineral Rent(as % of GDP) in Spain?
Ensure brevity in your answer.  0. In the year 1981, what is the difference between the Mineral Rent(as % of GDP) in Guatemala and Mineral Rent(as % of GDP) in Spain?
Provide a succinct answer. -0.02. In the year 1982, what is the difference between the Mineral Rent(as % of GDP) of High income: OECD and Mineral Rent(as % of GDP) of Argentina?
Offer a terse response. 0.06. In the year 1982, what is the difference between the Mineral Rent(as % of GDP) of High income: OECD and Mineral Rent(as % of GDP) of Guatemala?
Give a very brief answer. 0.08. In the year 1982, what is the difference between the Mineral Rent(as % of GDP) in High income: OECD and Mineral Rent(as % of GDP) in Spain?
Keep it short and to the point. 0.06. In the year 1982, what is the difference between the Mineral Rent(as % of GDP) of Argentina and Mineral Rent(as % of GDP) of Guatemala?
Provide a short and direct response. 0.02. In the year 1982, what is the difference between the Mineral Rent(as % of GDP) of Argentina and Mineral Rent(as % of GDP) of Spain?
Your answer should be compact. -0. In the year 1982, what is the difference between the Mineral Rent(as % of GDP) in Guatemala and Mineral Rent(as % of GDP) in Spain?
Provide a succinct answer. -0.02. In the year 1997, what is the difference between the Mineral Rent(as % of GDP) of High income: OECD and Mineral Rent(as % of GDP) of Argentina?
Keep it short and to the point. 0.03. In the year 1997, what is the difference between the Mineral Rent(as % of GDP) of High income: OECD and Mineral Rent(as % of GDP) of Guatemala?
Ensure brevity in your answer.  0.06. In the year 1997, what is the difference between the Mineral Rent(as % of GDP) of High income: OECD and Mineral Rent(as % of GDP) of Spain?
Provide a succinct answer. 0.05. In the year 1997, what is the difference between the Mineral Rent(as % of GDP) in Argentina and Mineral Rent(as % of GDP) in Guatemala?
Your response must be concise. 0.02. In the year 1997, what is the difference between the Mineral Rent(as % of GDP) of Argentina and Mineral Rent(as % of GDP) of Spain?
Keep it short and to the point. 0.02. In the year 1997, what is the difference between the Mineral Rent(as % of GDP) of Guatemala and Mineral Rent(as % of GDP) of Spain?
Offer a terse response. -0. What is the ratio of the Mineral Rent(as % of GDP) in High income: OECD in 1976 to that in 1977?
Provide a short and direct response. 1.26. What is the ratio of the Mineral Rent(as % of GDP) in Argentina in 1976 to that in 1977?
Offer a terse response. 0.9. What is the ratio of the Mineral Rent(as % of GDP) in Guatemala in 1976 to that in 1977?
Offer a very short reply. 1.36. What is the ratio of the Mineral Rent(as % of GDP) in Spain in 1976 to that in 1977?
Your answer should be compact. 1.39. What is the ratio of the Mineral Rent(as % of GDP) in High income: OECD in 1976 to that in 1978?
Offer a very short reply. 1.91. What is the ratio of the Mineral Rent(as % of GDP) in Argentina in 1976 to that in 1978?
Your answer should be compact. 1.25. What is the ratio of the Mineral Rent(as % of GDP) of Guatemala in 1976 to that in 1978?
Ensure brevity in your answer.  0.76. What is the ratio of the Mineral Rent(as % of GDP) of Spain in 1976 to that in 1978?
Your answer should be compact. 2.84. What is the ratio of the Mineral Rent(as % of GDP) of High income: OECD in 1976 to that in 1979?
Your response must be concise. 1.29. What is the ratio of the Mineral Rent(as % of GDP) of Argentina in 1976 to that in 1979?
Provide a succinct answer. 0.66. What is the ratio of the Mineral Rent(as % of GDP) in Guatemala in 1976 to that in 1979?
Offer a very short reply. 0.21. What is the ratio of the Mineral Rent(as % of GDP) in Spain in 1976 to that in 1979?
Offer a very short reply. 1.01. What is the ratio of the Mineral Rent(as % of GDP) in High income: OECD in 1976 to that in 1980?
Keep it short and to the point. 1.09. What is the ratio of the Mineral Rent(as % of GDP) of Argentina in 1976 to that in 1980?
Your answer should be very brief. 0.59. What is the ratio of the Mineral Rent(as % of GDP) of Guatemala in 1976 to that in 1980?
Give a very brief answer. 0.23. What is the ratio of the Mineral Rent(as % of GDP) in Spain in 1976 to that in 1980?
Make the answer very short. 0.71. What is the ratio of the Mineral Rent(as % of GDP) in High income: OECD in 1976 to that in 1981?
Make the answer very short. 1.52. What is the ratio of the Mineral Rent(as % of GDP) of Argentina in 1976 to that in 1981?
Make the answer very short. 1.29. What is the ratio of the Mineral Rent(as % of GDP) in Guatemala in 1976 to that in 1981?
Provide a short and direct response. 7.66. What is the ratio of the Mineral Rent(as % of GDP) of Spain in 1976 to that in 1981?
Offer a terse response. 1.53. What is the ratio of the Mineral Rent(as % of GDP) in High income: OECD in 1976 to that in 1982?
Ensure brevity in your answer.  1.88. What is the ratio of the Mineral Rent(as % of GDP) in Argentina in 1976 to that in 1982?
Offer a terse response. 2.05. What is the ratio of the Mineral Rent(as % of GDP) of Guatemala in 1976 to that in 1982?
Your response must be concise. 78.95. What is the ratio of the Mineral Rent(as % of GDP) of Spain in 1976 to that in 1982?
Your response must be concise. 1.94. What is the ratio of the Mineral Rent(as % of GDP) in High income: OECD in 1976 to that in 1997?
Provide a short and direct response. 2.82. What is the ratio of the Mineral Rent(as % of GDP) in Argentina in 1976 to that in 1997?
Provide a short and direct response. 1.84. What is the ratio of the Mineral Rent(as % of GDP) of Guatemala in 1976 to that in 1997?
Provide a succinct answer. 115.01. What is the ratio of the Mineral Rent(as % of GDP) in Spain in 1976 to that in 1997?
Offer a terse response. 15.99. What is the ratio of the Mineral Rent(as % of GDP) in High income: OECD in 1977 to that in 1978?
Keep it short and to the point. 1.52. What is the ratio of the Mineral Rent(as % of GDP) of Argentina in 1977 to that in 1978?
Your answer should be very brief. 1.38. What is the ratio of the Mineral Rent(as % of GDP) in Guatemala in 1977 to that in 1978?
Provide a short and direct response. 0.56. What is the ratio of the Mineral Rent(as % of GDP) in Spain in 1977 to that in 1978?
Ensure brevity in your answer.  2.04. What is the ratio of the Mineral Rent(as % of GDP) of High income: OECD in 1977 to that in 1979?
Your response must be concise. 1.02. What is the ratio of the Mineral Rent(as % of GDP) in Argentina in 1977 to that in 1979?
Your response must be concise. 0.73. What is the ratio of the Mineral Rent(as % of GDP) in Guatemala in 1977 to that in 1979?
Make the answer very short. 0.16. What is the ratio of the Mineral Rent(as % of GDP) in Spain in 1977 to that in 1979?
Give a very brief answer. 0.73. What is the ratio of the Mineral Rent(as % of GDP) of High income: OECD in 1977 to that in 1980?
Provide a succinct answer. 0.86. What is the ratio of the Mineral Rent(as % of GDP) of Argentina in 1977 to that in 1980?
Provide a succinct answer. 0.65. What is the ratio of the Mineral Rent(as % of GDP) of Guatemala in 1977 to that in 1980?
Ensure brevity in your answer.  0.17. What is the ratio of the Mineral Rent(as % of GDP) of Spain in 1977 to that in 1980?
Give a very brief answer. 0.51. What is the ratio of the Mineral Rent(as % of GDP) in High income: OECD in 1977 to that in 1981?
Provide a short and direct response. 1.2. What is the ratio of the Mineral Rent(as % of GDP) of Argentina in 1977 to that in 1981?
Make the answer very short. 1.43. What is the ratio of the Mineral Rent(as % of GDP) of Guatemala in 1977 to that in 1981?
Your answer should be very brief. 5.62. What is the ratio of the Mineral Rent(as % of GDP) in High income: OECD in 1977 to that in 1982?
Provide a succinct answer. 1.49. What is the ratio of the Mineral Rent(as % of GDP) in Argentina in 1977 to that in 1982?
Your answer should be compact. 2.27. What is the ratio of the Mineral Rent(as % of GDP) in Guatemala in 1977 to that in 1982?
Give a very brief answer. 57.89. What is the ratio of the Mineral Rent(as % of GDP) of Spain in 1977 to that in 1982?
Your answer should be compact. 1.4. What is the ratio of the Mineral Rent(as % of GDP) in High income: OECD in 1977 to that in 1997?
Offer a very short reply. 2.24. What is the ratio of the Mineral Rent(as % of GDP) of Argentina in 1977 to that in 1997?
Your response must be concise. 2.03. What is the ratio of the Mineral Rent(as % of GDP) of Guatemala in 1977 to that in 1997?
Offer a terse response. 84.32. What is the ratio of the Mineral Rent(as % of GDP) in Spain in 1977 to that in 1997?
Ensure brevity in your answer.  11.49. What is the ratio of the Mineral Rent(as % of GDP) in High income: OECD in 1978 to that in 1979?
Offer a very short reply. 0.67. What is the ratio of the Mineral Rent(as % of GDP) of Argentina in 1978 to that in 1979?
Make the answer very short. 0.53. What is the ratio of the Mineral Rent(as % of GDP) in Guatemala in 1978 to that in 1979?
Keep it short and to the point. 0.28. What is the ratio of the Mineral Rent(as % of GDP) of Spain in 1978 to that in 1979?
Offer a very short reply. 0.36. What is the ratio of the Mineral Rent(as % of GDP) of High income: OECD in 1978 to that in 1980?
Your response must be concise. 0.57. What is the ratio of the Mineral Rent(as % of GDP) of Argentina in 1978 to that in 1980?
Give a very brief answer. 0.47. What is the ratio of the Mineral Rent(as % of GDP) in Guatemala in 1978 to that in 1980?
Ensure brevity in your answer.  0.3. What is the ratio of the Mineral Rent(as % of GDP) of Spain in 1978 to that in 1980?
Offer a terse response. 0.25. What is the ratio of the Mineral Rent(as % of GDP) in High income: OECD in 1978 to that in 1981?
Your response must be concise. 0.79. What is the ratio of the Mineral Rent(as % of GDP) of Argentina in 1978 to that in 1981?
Offer a terse response. 1.03. What is the ratio of the Mineral Rent(as % of GDP) in Guatemala in 1978 to that in 1981?
Offer a very short reply. 10.06. What is the ratio of the Mineral Rent(as % of GDP) of Spain in 1978 to that in 1981?
Make the answer very short. 0.54. What is the ratio of the Mineral Rent(as % of GDP) in Argentina in 1978 to that in 1982?
Your answer should be very brief. 1.64. What is the ratio of the Mineral Rent(as % of GDP) in Guatemala in 1978 to that in 1982?
Your response must be concise. 103.71. What is the ratio of the Mineral Rent(as % of GDP) of Spain in 1978 to that in 1982?
Offer a very short reply. 0.68. What is the ratio of the Mineral Rent(as % of GDP) of High income: OECD in 1978 to that in 1997?
Your response must be concise. 1.48. What is the ratio of the Mineral Rent(as % of GDP) of Argentina in 1978 to that in 1997?
Give a very brief answer. 1.47. What is the ratio of the Mineral Rent(as % of GDP) in Guatemala in 1978 to that in 1997?
Offer a very short reply. 151.07. What is the ratio of the Mineral Rent(as % of GDP) of Spain in 1978 to that in 1997?
Make the answer very short. 5.63. What is the ratio of the Mineral Rent(as % of GDP) of High income: OECD in 1979 to that in 1980?
Give a very brief answer. 0.85. What is the ratio of the Mineral Rent(as % of GDP) in Argentina in 1979 to that in 1980?
Give a very brief answer. 0.9. What is the ratio of the Mineral Rent(as % of GDP) of Guatemala in 1979 to that in 1980?
Provide a short and direct response. 1.05. What is the ratio of the Mineral Rent(as % of GDP) of Spain in 1979 to that in 1980?
Provide a short and direct response. 0.7. What is the ratio of the Mineral Rent(as % of GDP) in High income: OECD in 1979 to that in 1981?
Provide a short and direct response. 1.18. What is the ratio of the Mineral Rent(as % of GDP) in Argentina in 1979 to that in 1981?
Provide a succinct answer. 1.96. What is the ratio of the Mineral Rent(as % of GDP) in Guatemala in 1979 to that in 1981?
Your answer should be very brief. 35.66. What is the ratio of the Mineral Rent(as % of GDP) of Spain in 1979 to that in 1981?
Give a very brief answer. 1.51. What is the ratio of the Mineral Rent(as % of GDP) in High income: OECD in 1979 to that in 1982?
Provide a succinct answer. 1.46. What is the ratio of the Mineral Rent(as % of GDP) of Argentina in 1979 to that in 1982?
Offer a very short reply. 3.12. What is the ratio of the Mineral Rent(as % of GDP) of Guatemala in 1979 to that in 1982?
Give a very brief answer. 367.51. What is the ratio of the Mineral Rent(as % of GDP) of Spain in 1979 to that in 1982?
Keep it short and to the point. 1.92. What is the ratio of the Mineral Rent(as % of GDP) of High income: OECD in 1979 to that in 1997?
Your answer should be very brief. 2.19. What is the ratio of the Mineral Rent(as % of GDP) in Argentina in 1979 to that in 1997?
Provide a short and direct response. 2.79. What is the ratio of the Mineral Rent(as % of GDP) of Guatemala in 1979 to that in 1997?
Provide a succinct answer. 535.34. What is the ratio of the Mineral Rent(as % of GDP) of Spain in 1979 to that in 1997?
Provide a succinct answer. 15.76. What is the ratio of the Mineral Rent(as % of GDP) in High income: OECD in 1980 to that in 1981?
Your response must be concise. 1.39. What is the ratio of the Mineral Rent(as % of GDP) in Argentina in 1980 to that in 1981?
Provide a succinct answer. 2.18. What is the ratio of the Mineral Rent(as % of GDP) in Guatemala in 1980 to that in 1981?
Offer a very short reply. 33.94. What is the ratio of the Mineral Rent(as % of GDP) of Spain in 1980 to that in 1981?
Your answer should be compact. 2.17. What is the ratio of the Mineral Rent(as % of GDP) of High income: OECD in 1980 to that in 1982?
Keep it short and to the point. 1.73. What is the ratio of the Mineral Rent(as % of GDP) in Argentina in 1980 to that in 1982?
Offer a terse response. 3.47. What is the ratio of the Mineral Rent(as % of GDP) in Guatemala in 1980 to that in 1982?
Provide a succinct answer. 349.73. What is the ratio of the Mineral Rent(as % of GDP) of Spain in 1980 to that in 1982?
Your answer should be compact. 2.75. What is the ratio of the Mineral Rent(as % of GDP) in High income: OECD in 1980 to that in 1997?
Provide a short and direct response. 2.59. What is the ratio of the Mineral Rent(as % of GDP) in Argentina in 1980 to that in 1997?
Your answer should be compact. 3.11. What is the ratio of the Mineral Rent(as % of GDP) in Guatemala in 1980 to that in 1997?
Keep it short and to the point. 509.44. What is the ratio of the Mineral Rent(as % of GDP) of Spain in 1980 to that in 1997?
Ensure brevity in your answer.  22.64. What is the ratio of the Mineral Rent(as % of GDP) of High income: OECD in 1981 to that in 1982?
Your answer should be compact. 1.24. What is the ratio of the Mineral Rent(as % of GDP) in Argentina in 1981 to that in 1982?
Your answer should be very brief. 1.59. What is the ratio of the Mineral Rent(as % of GDP) of Guatemala in 1981 to that in 1982?
Provide a succinct answer. 10.31. What is the ratio of the Mineral Rent(as % of GDP) in Spain in 1981 to that in 1982?
Give a very brief answer. 1.27. What is the ratio of the Mineral Rent(as % of GDP) in High income: OECD in 1981 to that in 1997?
Provide a succinct answer. 1.86. What is the ratio of the Mineral Rent(as % of GDP) of Argentina in 1981 to that in 1997?
Offer a very short reply. 1.43. What is the ratio of the Mineral Rent(as % of GDP) in Guatemala in 1981 to that in 1997?
Provide a succinct answer. 15.01. What is the ratio of the Mineral Rent(as % of GDP) of Spain in 1981 to that in 1997?
Provide a succinct answer. 10.45. What is the ratio of the Mineral Rent(as % of GDP) in High income: OECD in 1982 to that in 1997?
Ensure brevity in your answer.  1.5. What is the ratio of the Mineral Rent(as % of GDP) of Argentina in 1982 to that in 1997?
Provide a short and direct response. 0.9. What is the ratio of the Mineral Rent(as % of GDP) of Guatemala in 1982 to that in 1997?
Your response must be concise. 1.46. What is the ratio of the Mineral Rent(as % of GDP) of Spain in 1982 to that in 1997?
Offer a terse response. 8.23. What is the difference between the highest and the second highest Mineral Rent(as % of GDP) in High income: OECD?
Give a very brief answer. 0.01. What is the difference between the highest and the second highest Mineral Rent(as % of GDP) in Argentina?
Provide a short and direct response. 0.01. What is the difference between the highest and the second highest Mineral Rent(as % of GDP) of Guatemala?
Make the answer very short. 0.02. What is the difference between the highest and the second highest Mineral Rent(as % of GDP) in Spain?
Make the answer very short. 0.02. What is the difference between the highest and the lowest Mineral Rent(as % of GDP) of High income: OECD?
Your answer should be very brief. 0.1. What is the difference between the highest and the lowest Mineral Rent(as % of GDP) of Argentina?
Your answer should be compact. 0.05. What is the difference between the highest and the lowest Mineral Rent(as % of GDP) of Guatemala?
Your answer should be very brief. 0.33. What is the difference between the highest and the lowest Mineral Rent(as % of GDP) of Spain?
Provide a succinct answer. 0.06. 